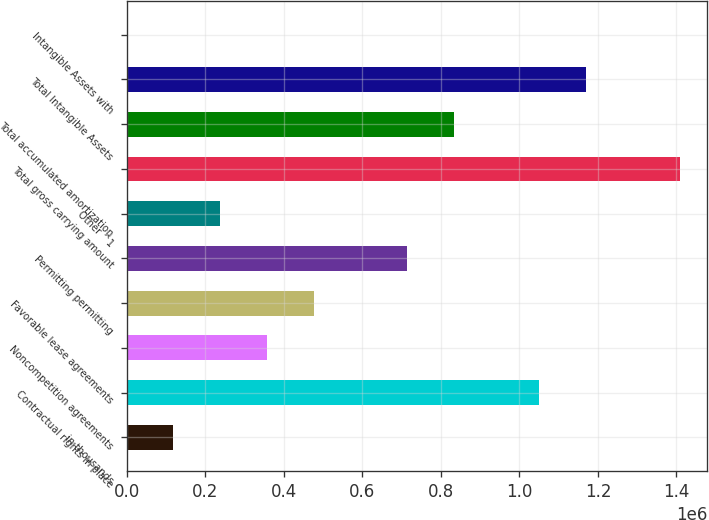Convert chart to OTSL. <chart><loc_0><loc_0><loc_500><loc_500><bar_chart><fcel>in thousands<fcel>Contractual rights in place<fcel>Noncompetition agreements<fcel>Favorable lease agreements<fcel>Permitting permitting<fcel>Other ^1<fcel>Total gross carrying amount<fcel>Total accumulated amortization<fcel>Total Intangible Assets<fcel>Intangible Assets with<nl><fcel>119100<fcel>1.05082e+06<fcel>357296<fcel>476393<fcel>714589<fcel>238198<fcel>1.40811e+06<fcel>833687<fcel>1.16991e+06<fcel>2.17<nl></chart> 